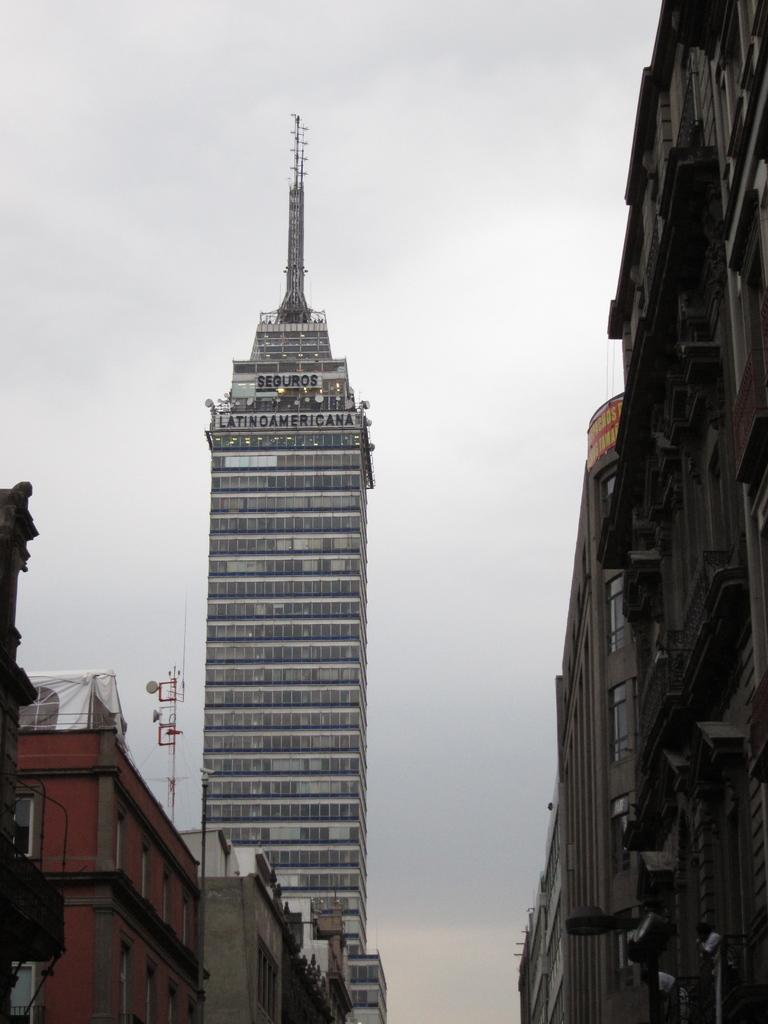What structures are present in the image? There are buildings in the image. What part of the natural environment is visible in the image? The sky is visible behind the buildings in the image. What type of street is visible in the image? There is no street visible in the image; it only features buildings and the sky. What kind of advice can be seen being given in the image? There is no advice present in the image; it only features buildings and the sky. 